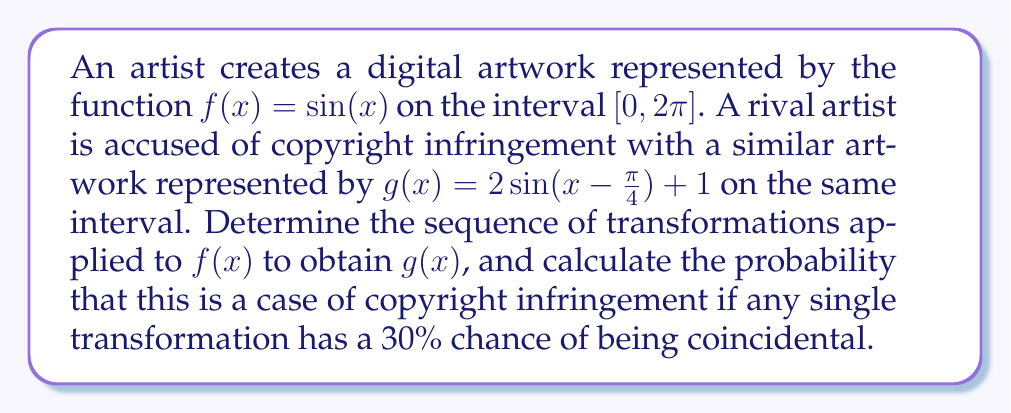Can you solve this math problem? To analyze the transformations from $f(x)$ to $g(x)$, we'll follow these steps:

1) Identify the transformations:
   $f(x) = \sin(x)$ to $g(x) = 2\sin(x - \frac{\pi}{4}) + 1$
   
   a) Dilation: The amplitude is doubled (2 outside the sine function)
   b) Translation horizontally: Shift right by $\frac{\pi}{4}$ (subtract inside the sine function)
   c) Translation vertically: Shift up by 1 (add 1 at the end)

2) Express the transformations mathematically:
   $$g(x) = 2f(x - \frac{\pi}{4}) + 1$$

3) Count the number of transformations: 3

4) Calculate the probability of coincidence:
   Probability of one transformation being coincidental = 30% = 0.3
   Probability of all three being coincidental = $0.3 \times 0.3 \times 0.3 = 0.027 = 2.7\%$

5) Calculate the probability of copyright infringement:
   $1 - 0.027 = 0.973 = 97.3\%$
Answer: 97.3% 